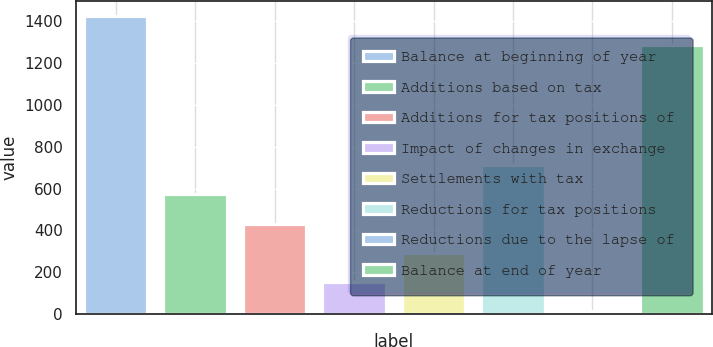Convert chart to OTSL. <chart><loc_0><loc_0><loc_500><loc_500><bar_chart><fcel>Balance at beginning of year<fcel>Additions based on tax<fcel>Additions for tax positions of<fcel>Impact of changes in exchange<fcel>Settlements with tax<fcel>Reductions for tax positions<fcel>Reductions due to the lapse of<fcel>Balance at end of year<nl><fcel>1423.4<fcel>571.6<fcel>433.2<fcel>156.4<fcel>294.8<fcel>710<fcel>18<fcel>1285<nl></chart> 